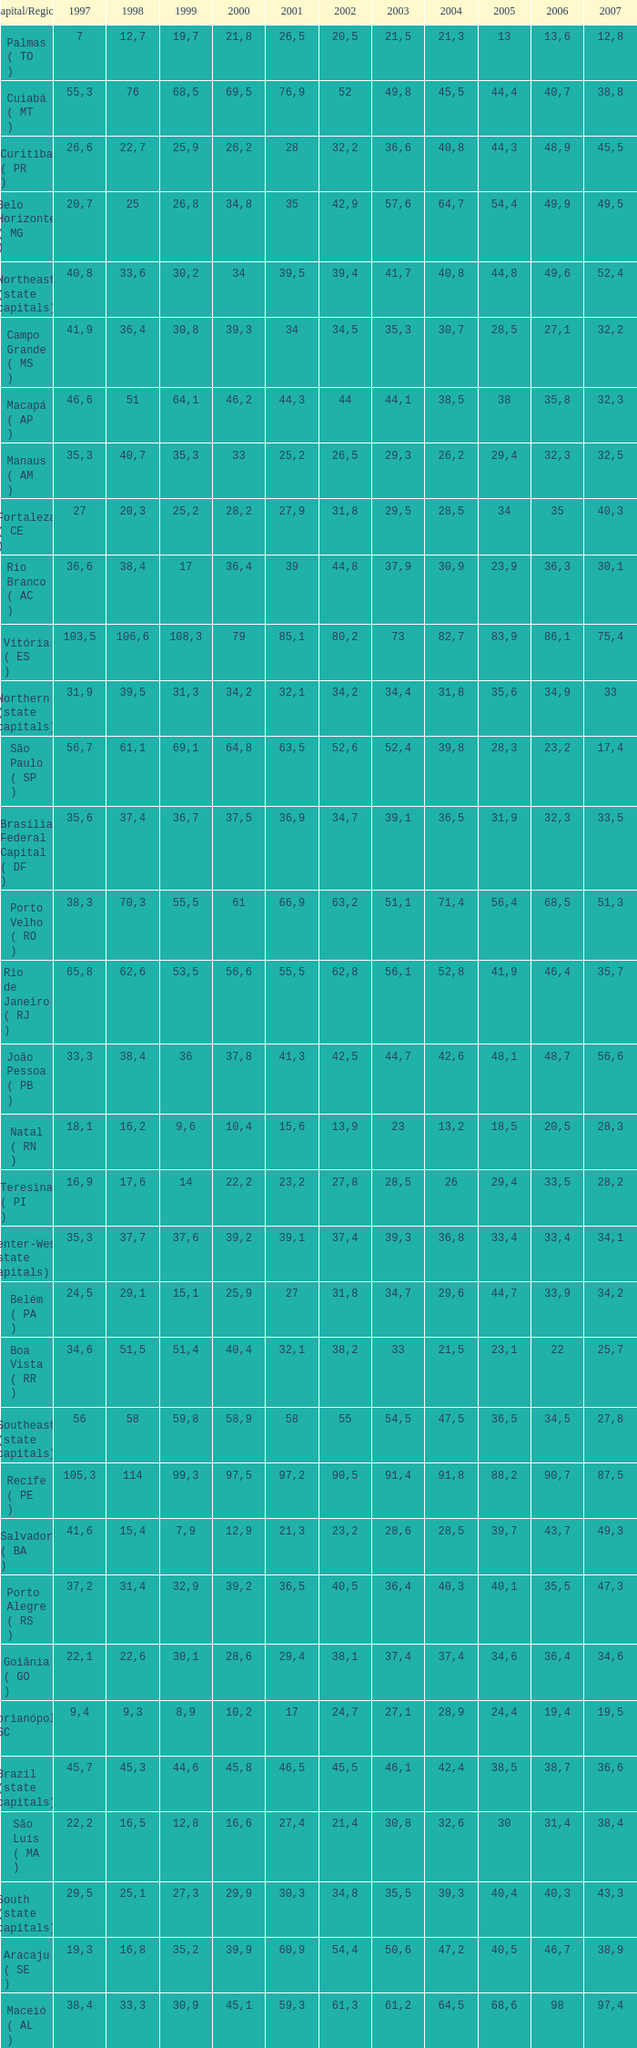How many 2007's have a 2000 greater than 56,6, 23,2 as 2006, and a 1998 greater than 61,1? None. 